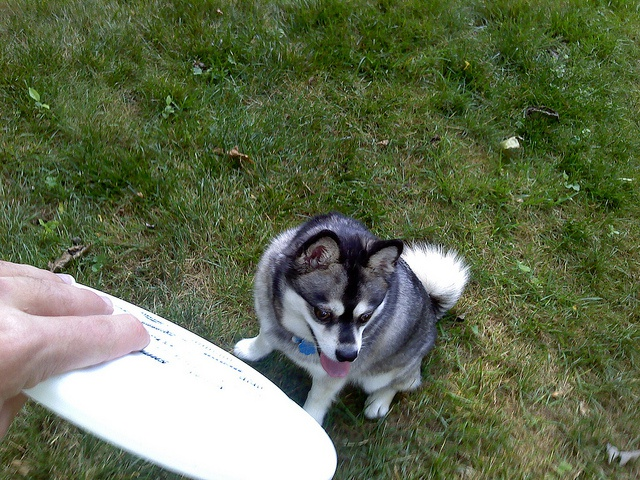Describe the objects in this image and their specific colors. I can see dog in green, gray, black, darkgray, and white tones, frisbee in green, white, darkgray, and lightblue tones, and people in green, lavender, darkgray, and pink tones in this image. 